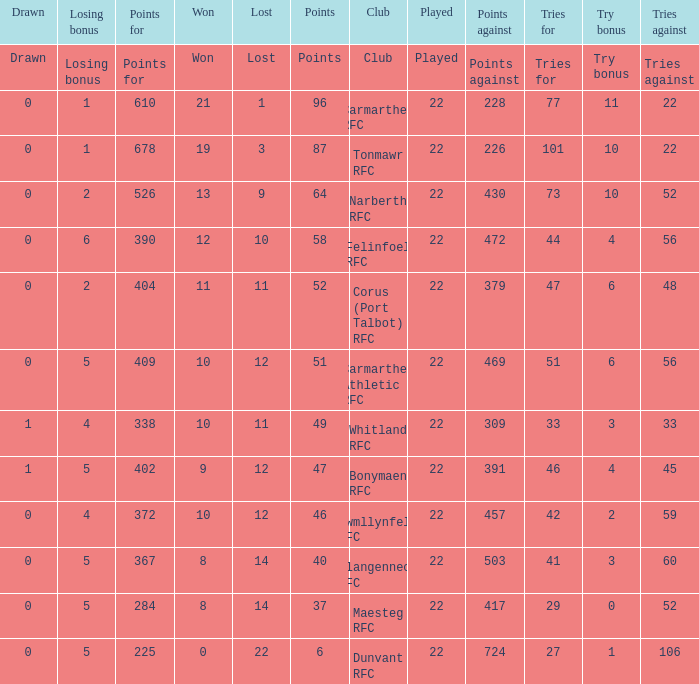Name the losing bonus for 27 5.0. 